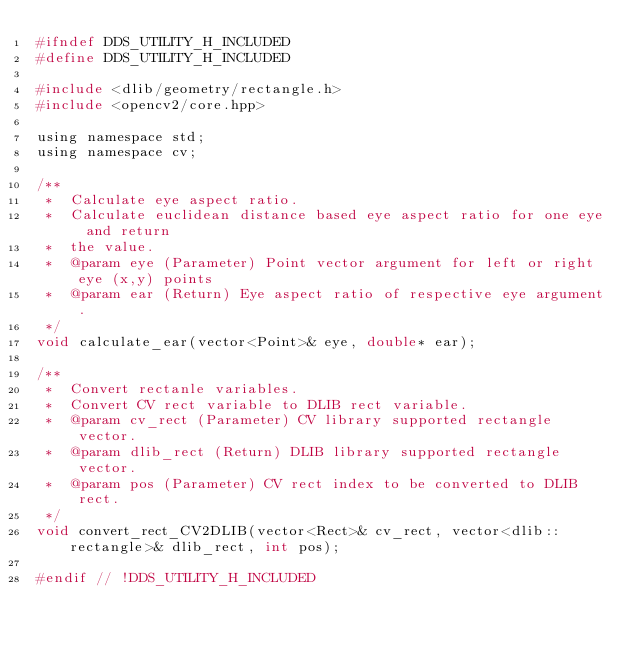Convert code to text. <code><loc_0><loc_0><loc_500><loc_500><_C_>#ifndef DDS_UTILITY_H_INCLUDED
#define DDS_UTILITY_H_INCLUDED

#include <dlib/geometry/rectangle.h>
#include <opencv2/core.hpp>

using namespace std;
using namespace cv;

/**
 *  Calculate eye aspect ratio.
 *  Calculate euclidean distance based eye aspect ratio for one eye and return
 *  the value.
 *  @param eye (Parameter) Point vector argument for left or right eye (x,y) points
 *  @param ear (Return) Eye aspect ratio of respective eye argument.
 */
void calculate_ear(vector<Point>& eye, double* ear);

/**
 *  Convert rectanle variables.
 *  Convert CV rect variable to DLIB rect variable.
 *  @param cv_rect (Parameter) CV library supported rectangle vector.
 *  @param dlib_rect (Return) DLIB library supported rectangle vector.
 *  @param pos (Parameter) CV rect index to be converted to DLIB rect.
 */
void convert_rect_CV2DLIB(vector<Rect>& cv_rect, vector<dlib::rectangle>& dlib_rect, int pos);

#endif // !DDS_UTILITY_H_INCLUDED</code> 